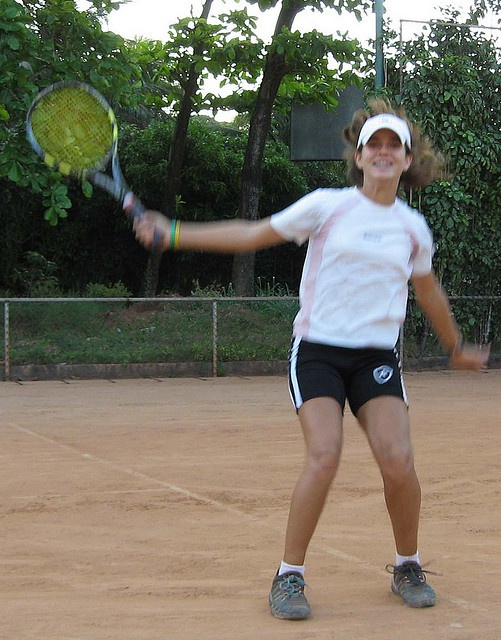Describe the objects in this image and their specific colors. I can see people in green, black, gray, lavender, and lightblue tones and tennis racket in green, olive, gray, and black tones in this image. 